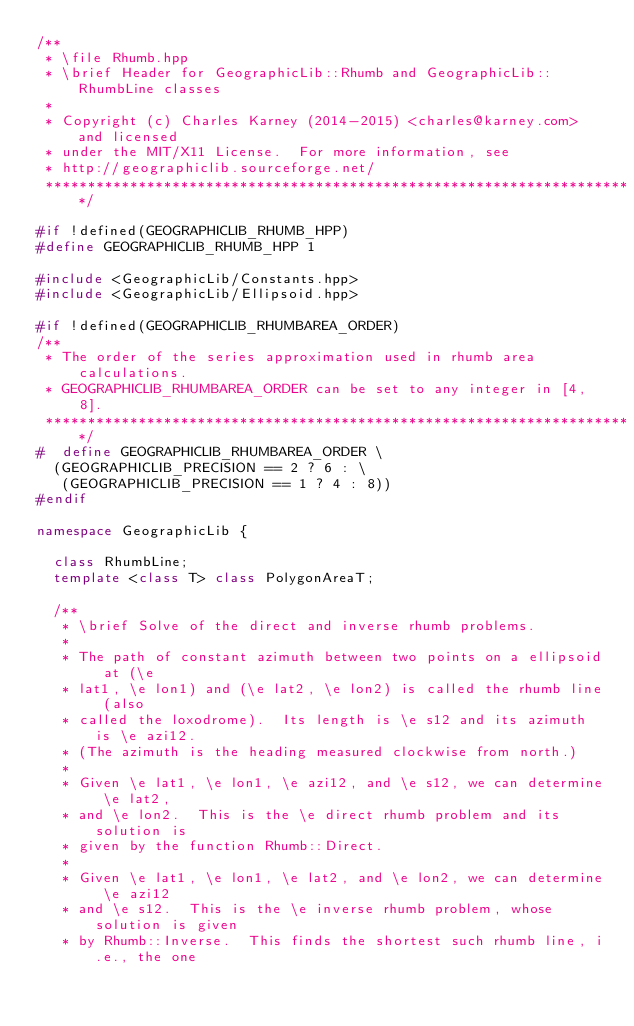Convert code to text. <code><loc_0><loc_0><loc_500><loc_500><_C++_>/**
 * \file Rhumb.hpp
 * \brief Header for GeographicLib::Rhumb and GeographicLib::RhumbLine classes
 *
 * Copyright (c) Charles Karney (2014-2015) <charles@karney.com> and licensed
 * under the MIT/X11 License.  For more information, see
 * http://geographiclib.sourceforge.net/
 **********************************************************************/

#if !defined(GEOGRAPHICLIB_RHUMB_HPP)
#define GEOGRAPHICLIB_RHUMB_HPP 1

#include <GeographicLib/Constants.hpp>
#include <GeographicLib/Ellipsoid.hpp>

#if !defined(GEOGRAPHICLIB_RHUMBAREA_ORDER)
/**
 * The order of the series approximation used in rhumb area calculations.
 * GEOGRAPHICLIB_RHUMBAREA_ORDER can be set to any integer in [4, 8].
 **********************************************************************/
#  define GEOGRAPHICLIB_RHUMBAREA_ORDER \
  (GEOGRAPHICLIB_PRECISION == 2 ? 6 : \
   (GEOGRAPHICLIB_PRECISION == 1 ? 4 : 8))
#endif

namespace GeographicLib {

  class RhumbLine;
  template <class T> class PolygonAreaT;

  /**
   * \brief Solve of the direct and inverse rhumb problems.
   *
   * The path of constant azimuth between two points on a ellipsoid at (\e
   * lat1, \e lon1) and (\e lat2, \e lon2) is called the rhumb line (also
   * called the loxodrome).  Its length is \e s12 and its azimuth is \e azi12.
   * (The azimuth is the heading measured clockwise from north.)
   *
   * Given \e lat1, \e lon1, \e azi12, and \e s12, we can determine \e lat2,
   * and \e lon2.  This is the \e direct rhumb problem and its solution is
   * given by the function Rhumb::Direct.
   *
   * Given \e lat1, \e lon1, \e lat2, and \e lon2, we can determine \e azi12
   * and \e s12.  This is the \e inverse rhumb problem, whose solution is given
   * by Rhumb::Inverse.  This finds the shortest such rhumb line, i.e., the one</code> 